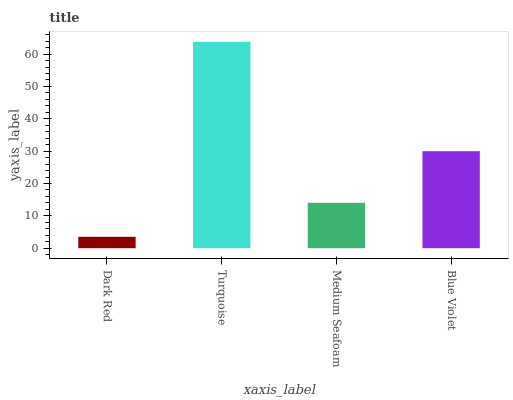Is Dark Red the minimum?
Answer yes or no. Yes. Is Turquoise the maximum?
Answer yes or no. Yes. Is Medium Seafoam the minimum?
Answer yes or no. No. Is Medium Seafoam the maximum?
Answer yes or no. No. Is Turquoise greater than Medium Seafoam?
Answer yes or no. Yes. Is Medium Seafoam less than Turquoise?
Answer yes or no. Yes. Is Medium Seafoam greater than Turquoise?
Answer yes or no. No. Is Turquoise less than Medium Seafoam?
Answer yes or no. No. Is Blue Violet the high median?
Answer yes or no. Yes. Is Medium Seafoam the low median?
Answer yes or no. Yes. Is Turquoise the high median?
Answer yes or no. No. Is Blue Violet the low median?
Answer yes or no. No. 